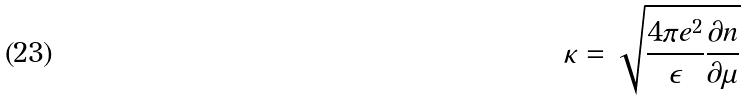Convert formula to latex. <formula><loc_0><loc_0><loc_500><loc_500>\kappa = \sqrt { \frac { 4 \pi e ^ { 2 } } { \epsilon } \frac { \partial n } { \partial \mu } }</formula> 